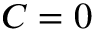Convert formula to latex. <formula><loc_0><loc_0><loc_500><loc_500>C = 0</formula> 